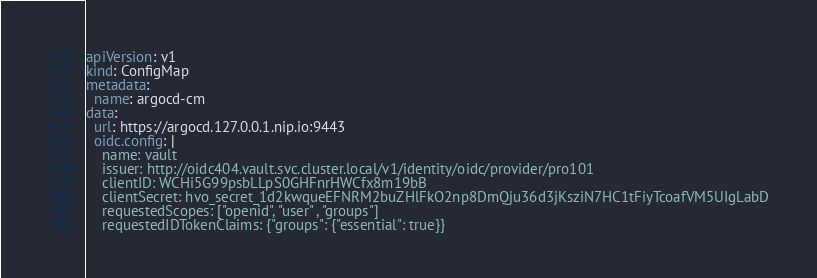<code> <loc_0><loc_0><loc_500><loc_500><_YAML_>apiVersion: v1
kind: ConfigMap
metadata:
  name: argocd-cm
data:
  url: https://argocd.127.0.0.1.nip.io:9443
  oidc.config: |
    name: vault
    issuer: http://oidc404.vault.svc.cluster.local/v1/identity/oidc/provider/pro101
    clientID: WCHi5G99psbLLpS0GHFnrHWCfx8m19bB
    clientSecret: hvo_secret_1d2kwqueEFNRM2buZHlFkO2np8DmQju36d3jKsziN7HC1tFiyTcoafVM5UIgLabD
    requestedScopes: ["openid", "user" , "groups"]
    requestedIDTokenClaims: {"groups": {"essential": true}}</code> 